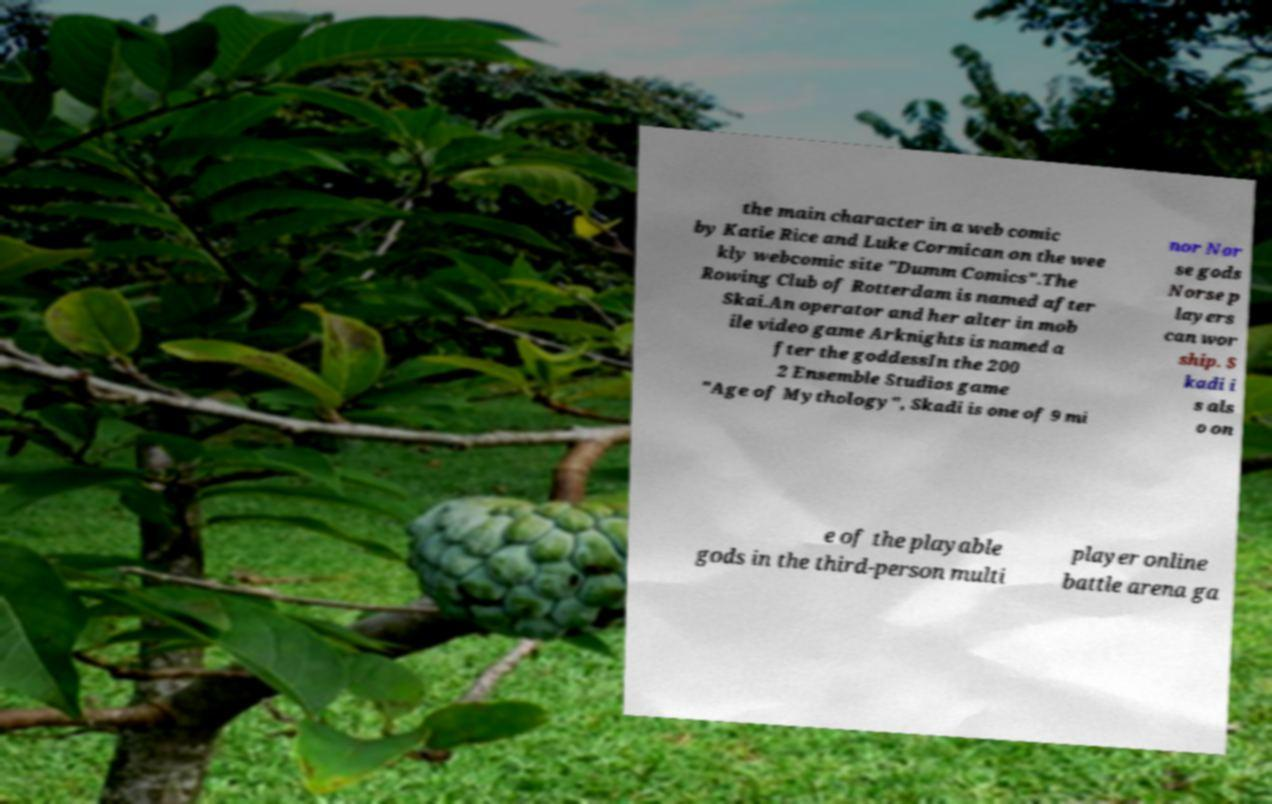Can you accurately transcribe the text from the provided image for me? the main character in a web comic by Katie Rice and Luke Cormican on the wee kly webcomic site "Dumm Comics".The Rowing Club of Rotterdam is named after Skai.An operator and her alter in mob ile video game Arknights is named a fter the goddessIn the 200 2 Ensemble Studios game "Age of Mythology", Skadi is one of 9 mi nor Nor se gods Norse p layers can wor ship. S kadi i s als o on e of the playable gods in the third-person multi player online battle arena ga 